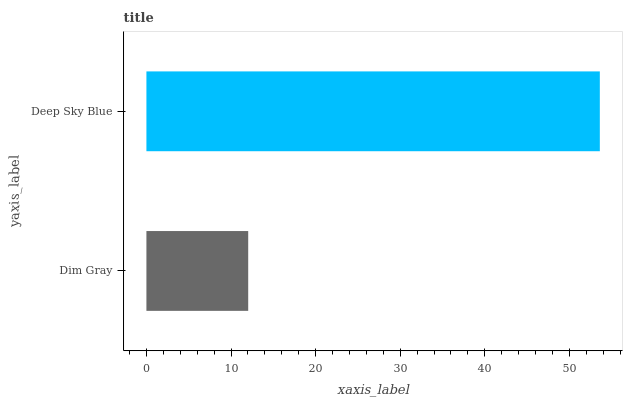Is Dim Gray the minimum?
Answer yes or no. Yes. Is Deep Sky Blue the maximum?
Answer yes or no. Yes. Is Deep Sky Blue the minimum?
Answer yes or no. No. Is Deep Sky Blue greater than Dim Gray?
Answer yes or no. Yes. Is Dim Gray less than Deep Sky Blue?
Answer yes or no. Yes. Is Dim Gray greater than Deep Sky Blue?
Answer yes or no. No. Is Deep Sky Blue less than Dim Gray?
Answer yes or no. No. Is Deep Sky Blue the high median?
Answer yes or no. Yes. Is Dim Gray the low median?
Answer yes or no. Yes. Is Dim Gray the high median?
Answer yes or no. No. Is Deep Sky Blue the low median?
Answer yes or no. No. 